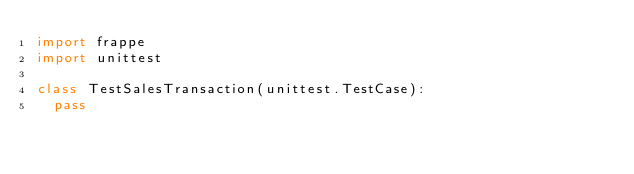Convert code to text. <code><loc_0><loc_0><loc_500><loc_500><_Python_>import frappe
import unittest

class TestSalesTransaction(unittest.TestCase):
	pass
</code> 